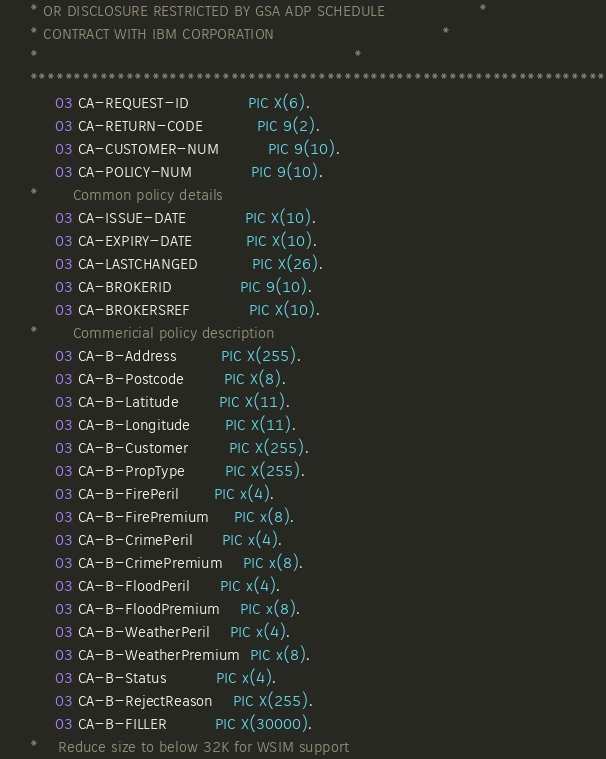Convert code to text. <code><loc_0><loc_0><loc_500><loc_500><_COBOL_>      * OR DISCLOSURE RESTRICTED BY GSA ADP SCHEDULE                   *
      * CONTRACT WITH IBM CORPORATION                                  *
      *                                                                *
      ******************************************************************
           03 CA-REQUEST-ID            PIC X(6).
           03 CA-RETURN-CODE           PIC 9(2).
           03 CA-CUSTOMER-NUM          PIC 9(10).
           03 CA-POLICY-NUM            PIC 9(10).
      *       Common policy details
           03 CA-ISSUE-DATE            PIC X(10).
           03 CA-EXPIRY-DATE           PIC X(10).
           03 CA-LASTCHANGED           PIC X(26).
           03 CA-BROKERID              PIC 9(10).
           03 CA-BROKERSREF            PIC X(10).
      *       Commericial policy description
           03 CA-B-Address         PIC X(255).
           03 CA-B-Postcode        PIC X(8).
           03 CA-B-Latitude        PIC X(11).
           03 CA-B-Longitude       PIC X(11).
           03 CA-B-Customer        PIC X(255).
           03 CA-B-PropType        PIC X(255).
           03 CA-B-FirePeril       PIC x(4).
           03 CA-B-FirePremium     PIC x(8).
           03 CA-B-CrimePeril      PIC x(4).
           03 CA-B-CrimePremium    PIC x(8).
           03 CA-B-FloodPeril      PIC x(4).
           03 CA-B-FloodPremium    PIC x(8).
           03 CA-B-WeatherPeril    PIC x(4).
           03 CA-B-WeatherPremium  PIC x(8).
           03 CA-B-Status          PIC x(4).
           03 CA-B-RejectReason    PIC X(255).
           03 CA-B-FILLER          PIC X(30000).
      *    Reduce size to below 32K for WSIM support
</code> 